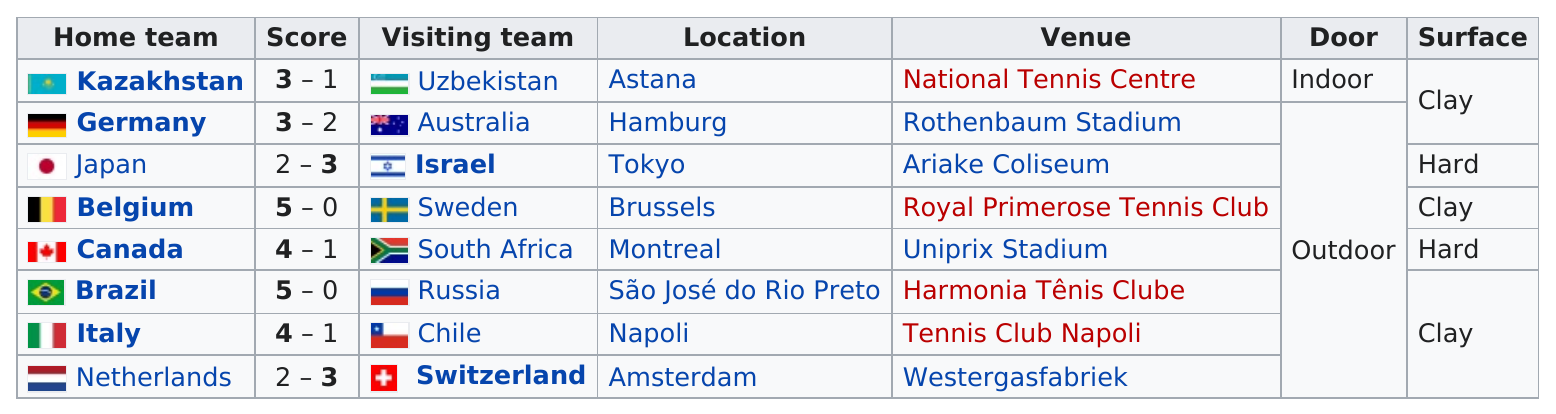Specify some key components in this picture. Out of the total number of teams that won by a margin of two or more points, 5 were identified. It is predicted that Belgium will be the other team, besides Brazil, to score 5 goals in this match. Four teams won by a margin of at least three points. The surface of most games was clay. In total, 1 game was played indoors. 